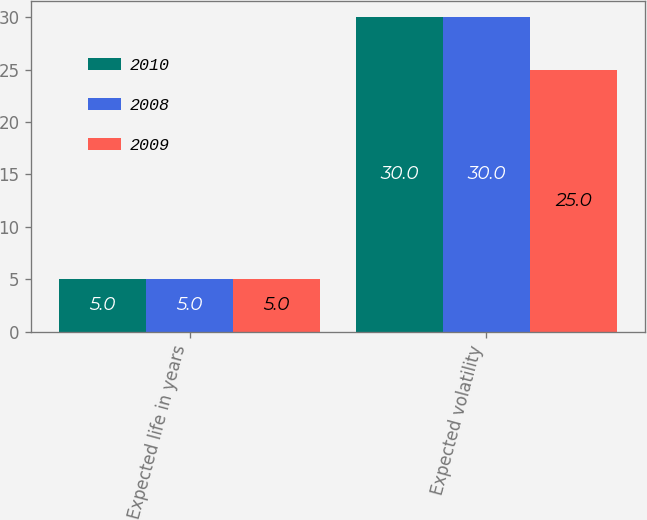Convert chart to OTSL. <chart><loc_0><loc_0><loc_500><loc_500><stacked_bar_chart><ecel><fcel>Expected life in years<fcel>Expected volatility<nl><fcel>2010<fcel>5<fcel>30<nl><fcel>2008<fcel>5<fcel>30<nl><fcel>2009<fcel>5<fcel>25<nl></chart> 